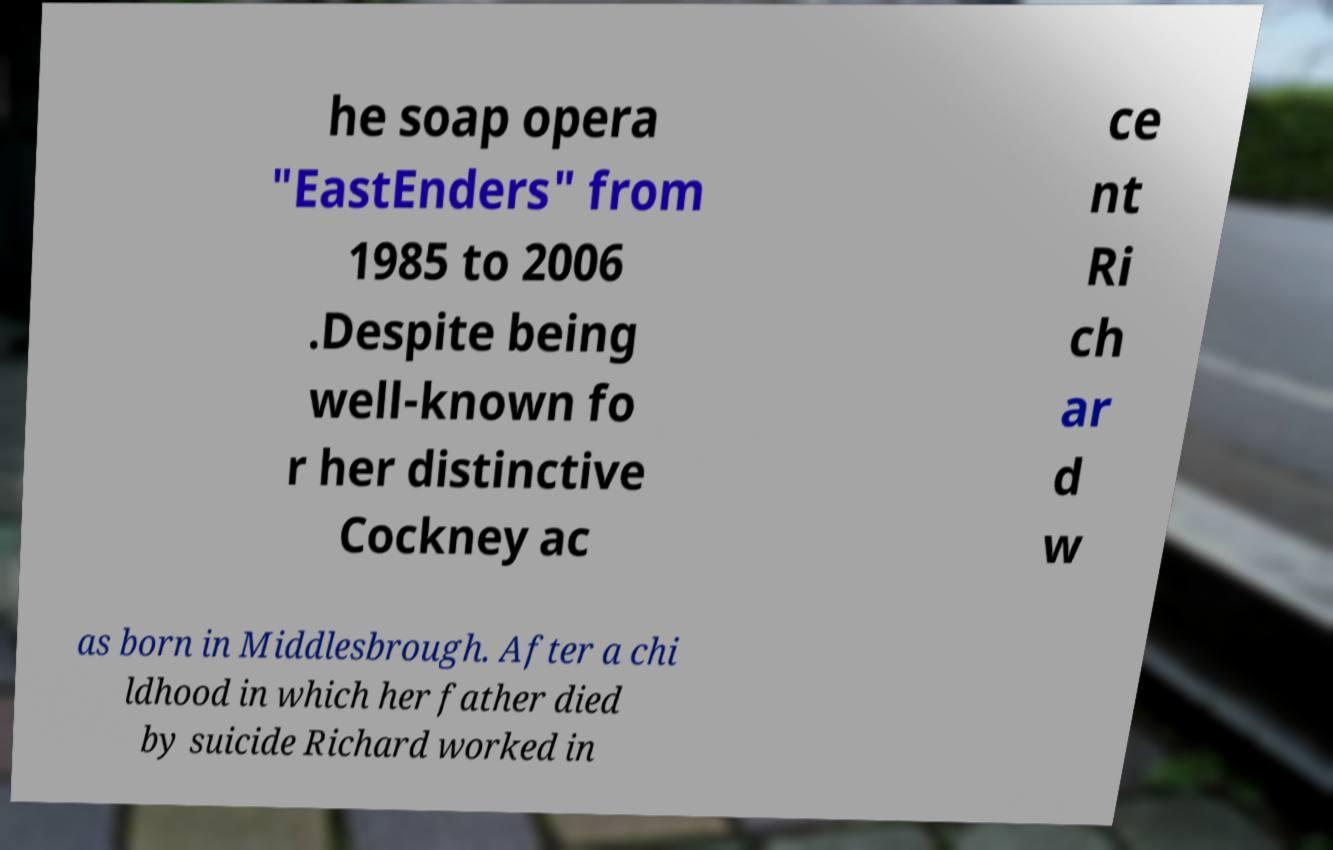For documentation purposes, I need the text within this image transcribed. Could you provide that? he soap opera "EastEnders" from 1985 to 2006 .Despite being well-known fo r her distinctive Cockney ac ce nt Ri ch ar d w as born in Middlesbrough. After a chi ldhood in which her father died by suicide Richard worked in 